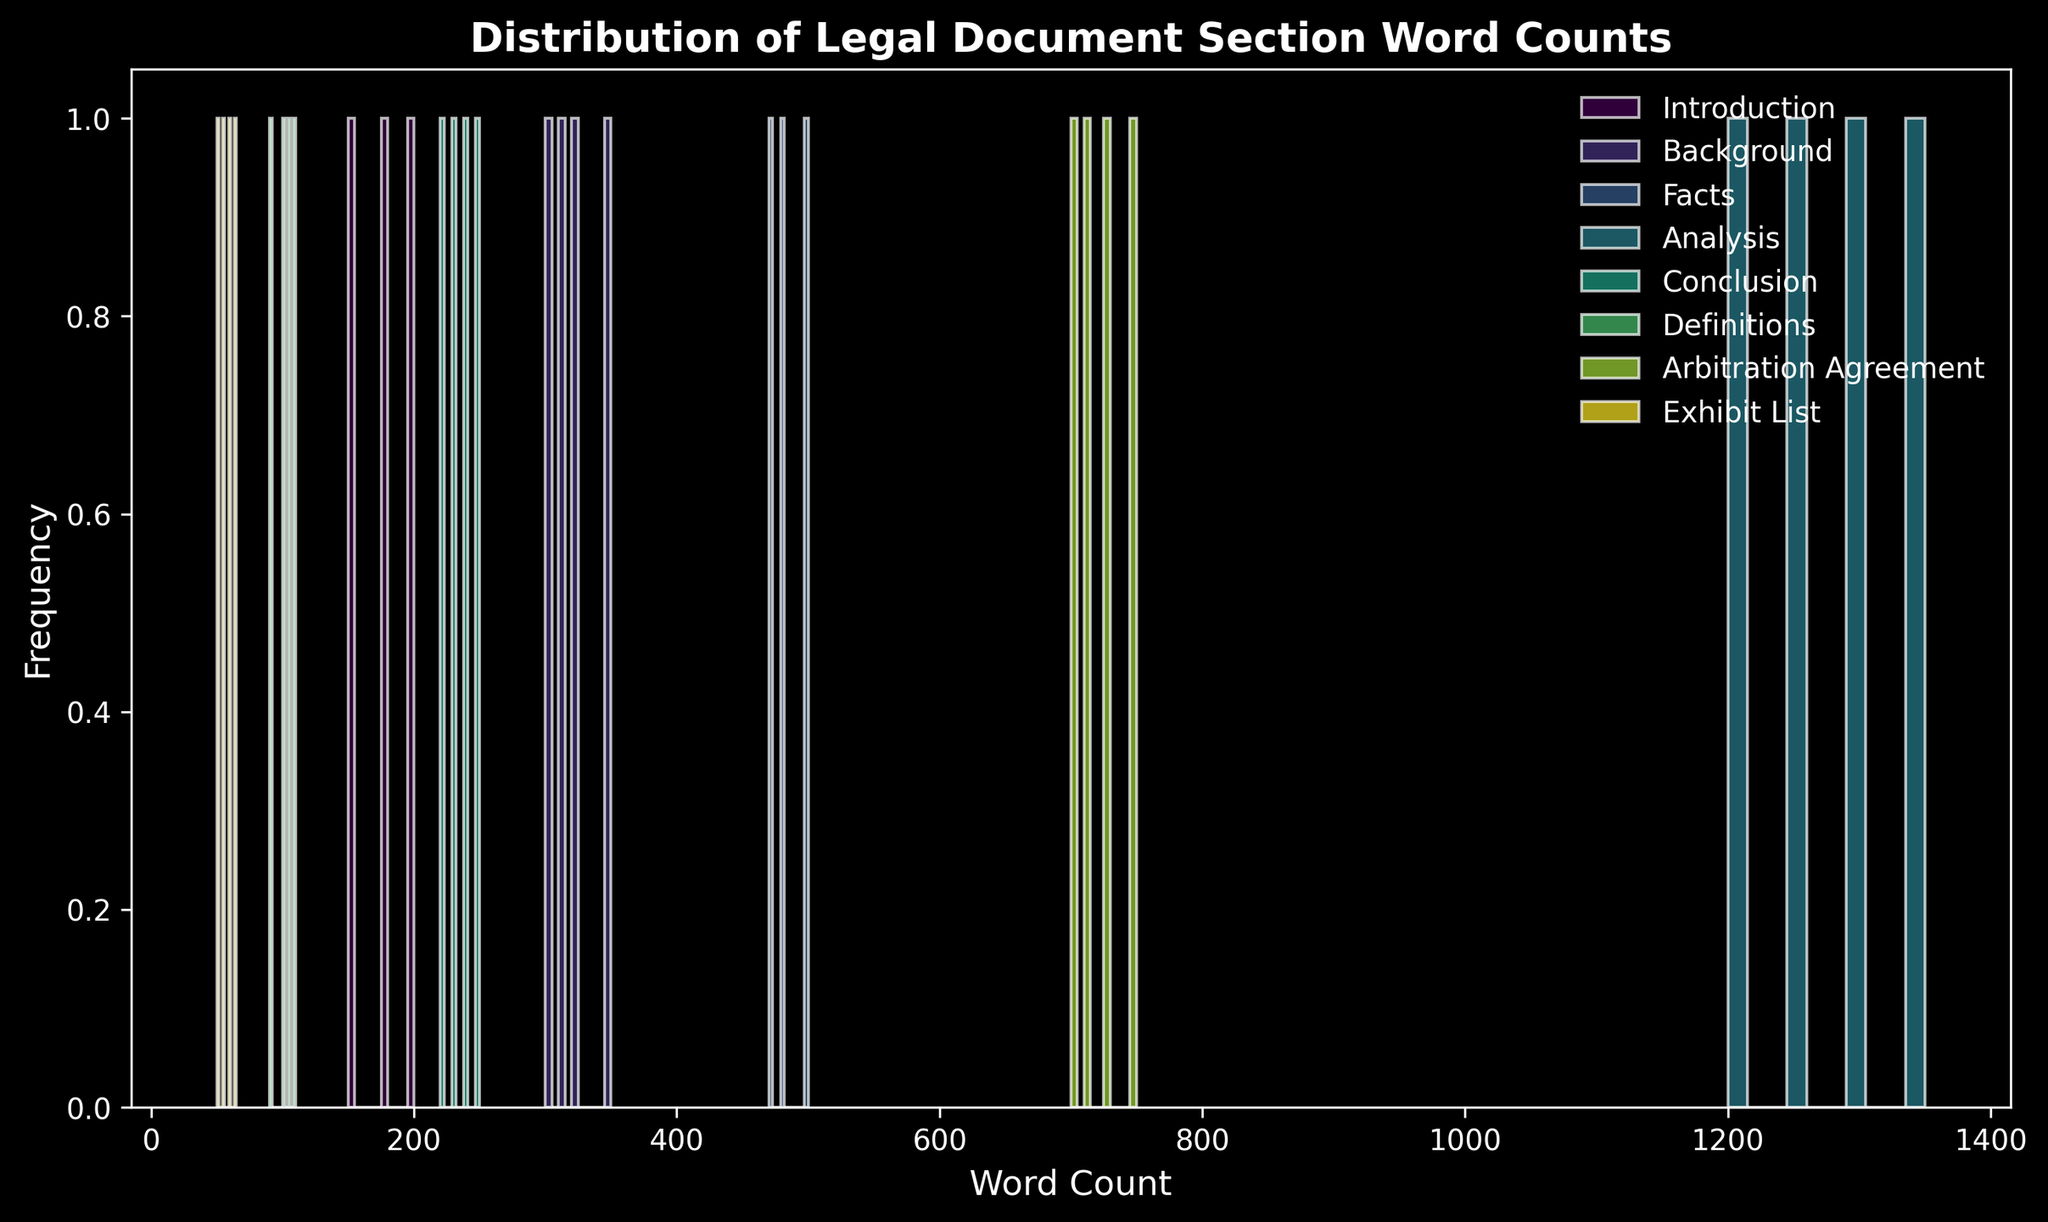Which section has the widest distribution of word counts? The width of the distribution can be identified by the range of word counts spread over the x-axis. The section "Analysis" has word counts ranging from around 1200 to 1350, which is the widest spread compared to other sections.
Answer: Analysis Which section has the highest frequency peak in the histogram? The frequency peak can be identified by the height of the bars. "Analysis" has the highest peak with word counts frequently occurring around the 1200-1350 range.
Answer: Analysis Is the word count distribution of the "Exhibit List" section mainly concentrated in a specific range? To check concentration, look at the area with the highest frequency of bars. The word counts for the "Exhibit List" are mainly concentrated around the 50-65 range.
Answer: Yes Do the word counts for the "Background" section overlap with those for the "Facts" section? Overlap can be determined if both sections share a range of word counts along the x-axis. The "Background" section word counts range from 300-350, and "Facts" range from 470-500, hence there is no overlap.
Answer: No Which section has word counts closest to the lower end of the word count spectrum? The shortest word counts in the histogram are for the "Exhibit List" section, with counts around 50-65.
Answer: Exhibit List What is the approximate word count range for the "Arbitration Agreement" section? The range of word counts for the "Arbitration Agreement" section can be seen between the smallest and largest bars. This section ranges from around 700 to 750.
Answer: 700-750 How do the word count ranges of the "Conclusion" and "Introduction" sections compare? By comparing the ranges visually, the "Introduction" section ranges from 150-200, whereas the "Conclusion" section ranges from 220-250. Thus, the "Conclusion" section has higher word counts overall.
Answer: Conclusion is higher What is the least frequent word count range for the "Definitions" section? To determine the least frequent range, look at the smaller bars for this section. The range of 100-110 for "Definitions" appears less frequent compared to the clusters around 90-100 and 105-110.
Answer: 100-110 